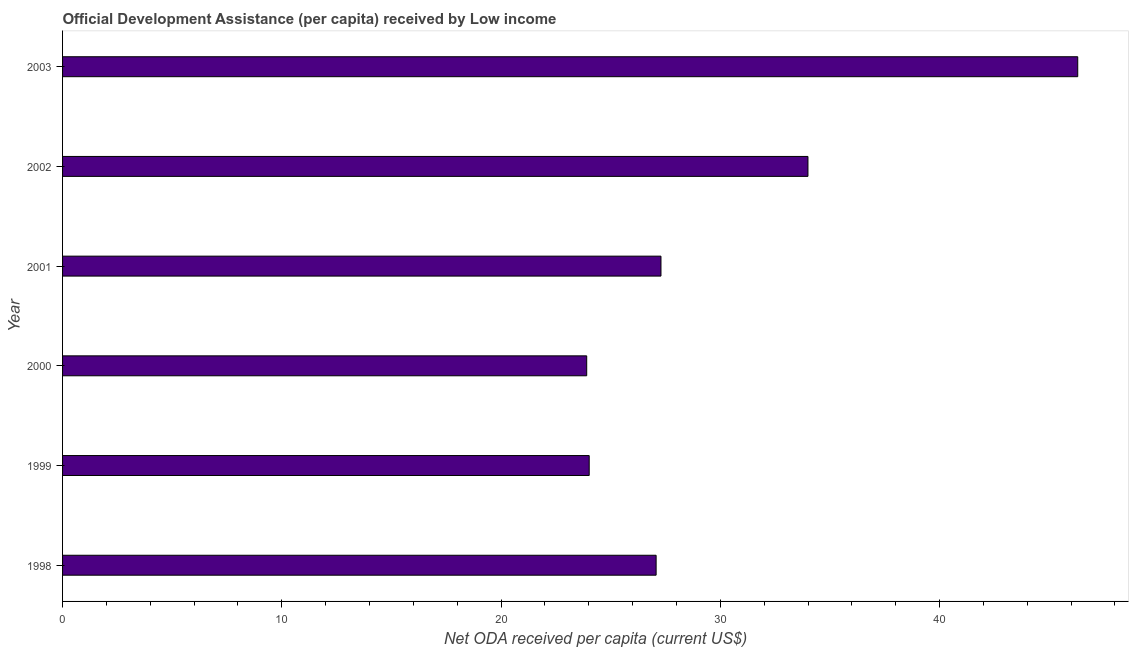Does the graph contain any zero values?
Ensure brevity in your answer.  No. Does the graph contain grids?
Give a very brief answer. No. What is the title of the graph?
Make the answer very short. Official Development Assistance (per capita) received by Low income. What is the label or title of the X-axis?
Provide a succinct answer. Net ODA received per capita (current US$). What is the net oda received per capita in 1999?
Your answer should be very brief. 24.02. Across all years, what is the maximum net oda received per capita?
Your answer should be very brief. 46.3. Across all years, what is the minimum net oda received per capita?
Your answer should be compact. 23.91. In which year was the net oda received per capita minimum?
Your response must be concise. 2000. What is the sum of the net oda received per capita?
Your answer should be compact. 182.6. What is the difference between the net oda received per capita in 1998 and 2001?
Offer a very short reply. -0.22. What is the average net oda received per capita per year?
Make the answer very short. 30.43. What is the median net oda received per capita?
Make the answer very short. 27.18. In how many years, is the net oda received per capita greater than 2 US$?
Your answer should be compact. 6. Do a majority of the years between 2003 and 2001 (inclusive) have net oda received per capita greater than 10 US$?
Give a very brief answer. Yes. What is the ratio of the net oda received per capita in 1998 to that in 2003?
Keep it short and to the point. 0.58. Is the net oda received per capita in 1998 less than that in 2002?
Your answer should be compact. Yes. What is the difference between the highest and the second highest net oda received per capita?
Your answer should be compact. 12.3. What is the difference between the highest and the lowest net oda received per capita?
Your answer should be compact. 22.4. Are all the bars in the graph horizontal?
Offer a very short reply. Yes. Are the values on the major ticks of X-axis written in scientific E-notation?
Offer a very short reply. No. What is the Net ODA received per capita (current US$) in 1998?
Offer a very short reply. 27.07. What is the Net ODA received per capita (current US$) of 1999?
Provide a succinct answer. 24.02. What is the Net ODA received per capita (current US$) in 2000?
Give a very brief answer. 23.91. What is the Net ODA received per capita (current US$) of 2001?
Make the answer very short. 27.29. What is the Net ODA received per capita (current US$) in 2002?
Your answer should be very brief. 34. What is the Net ODA received per capita (current US$) in 2003?
Your answer should be compact. 46.3. What is the difference between the Net ODA received per capita (current US$) in 1998 and 1999?
Give a very brief answer. 3.05. What is the difference between the Net ODA received per capita (current US$) in 1998 and 2000?
Keep it short and to the point. 3.17. What is the difference between the Net ODA received per capita (current US$) in 1998 and 2001?
Give a very brief answer. -0.22. What is the difference between the Net ODA received per capita (current US$) in 1998 and 2002?
Make the answer very short. -6.93. What is the difference between the Net ODA received per capita (current US$) in 1998 and 2003?
Provide a short and direct response. -19.23. What is the difference between the Net ODA received per capita (current US$) in 1999 and 2000?
Keep it short and to the point. 0.11. What is the difference between the Net ODA received per capita (current US$) in 1999 and 2001?
Your answer should be very brief. -3.27. What is the difference between the Net ODA received per capita (current US$) in 1999 and 2002?
Keep it short and to the point. -9.98. What is the difference between the Net ODA received per capita (current US$) in 1999 and 2003?
Offer a very short reply. -22.28. What is the difference between the Net ODA received per capita (current US$) in 2000 and 2001?
Offer a terse response. -3.39. What is the difference between the Net ODA received per capita (current US$) in 2000 and 2002?
Provide a succinct answer. -10.09. What is the difference between the Net ODA received per capita (current US$) in 2000 and 2003?
Give a very brief answer. -22.4. What is the difference between the Net ODA received per capita (current US$) in 2001 and 2002?
Make the answer very short. -6.7. What is the difference between the Net ODA received per capita (current US$) in 2001 and 2003?
Make the answer very short. -19.01. What is the difference between the Net ODA received per capita (current US$) in 2002 and 2003?
Your response must be concise. -12.3. What is the ratio of the Net ODA received per capita (current US$) in 1998 to that in 1999?
Provide a short and direct response. 1.13. What is the ratio of the Net ODA received per capita (current US$) in 1998 to that in 2000?
Keep it short and to the point. 1.13. What is the ratio of the Net ODA received per capita (current US$) in 1998 to that in 2002?
Ensure brevity in your answer.  0.8. What is the ratio of the Net ODA received per capita (current US$) in 1998 to that in 2003?
Your answer should be compact. 0.58. What is the ratio of the Net ODA received per capita (current US$) in 1999 to that in 2002?
Provide a short and direct response. 0.71. What is the ratio of the Net ODA received per capita (current US$) in 1999 to that in 2003?
Your answer should be very brief. 0.52. What is the ratio of the Net ODA received per capita (current US$) in 2000 to that in 2001?
Keep it short and to the point. 0.88. What is the ratio of the Net ODA received per capita (current US$) in 2000 to that in 2002?
Offer a terse response. 0.7. What is the ratio of the Net ODA received per capita (current US$) in 2000 to that in 2003?
Offer a very short reply. 0.52. What is the ratio of the Net ODA received per capita (current US$) in 2001 to that in 2002?
Provide a short and direct response. 0.8. What is the ratio of the Net ODA received per capita (current US$) in 2001 to that in 2003?
Offer a very short reply. 0.59. What is the ratio of the Net ODA received per capita (current US$) in 2002 to that in 2003?
Provide a short and direct response. 0.73. 